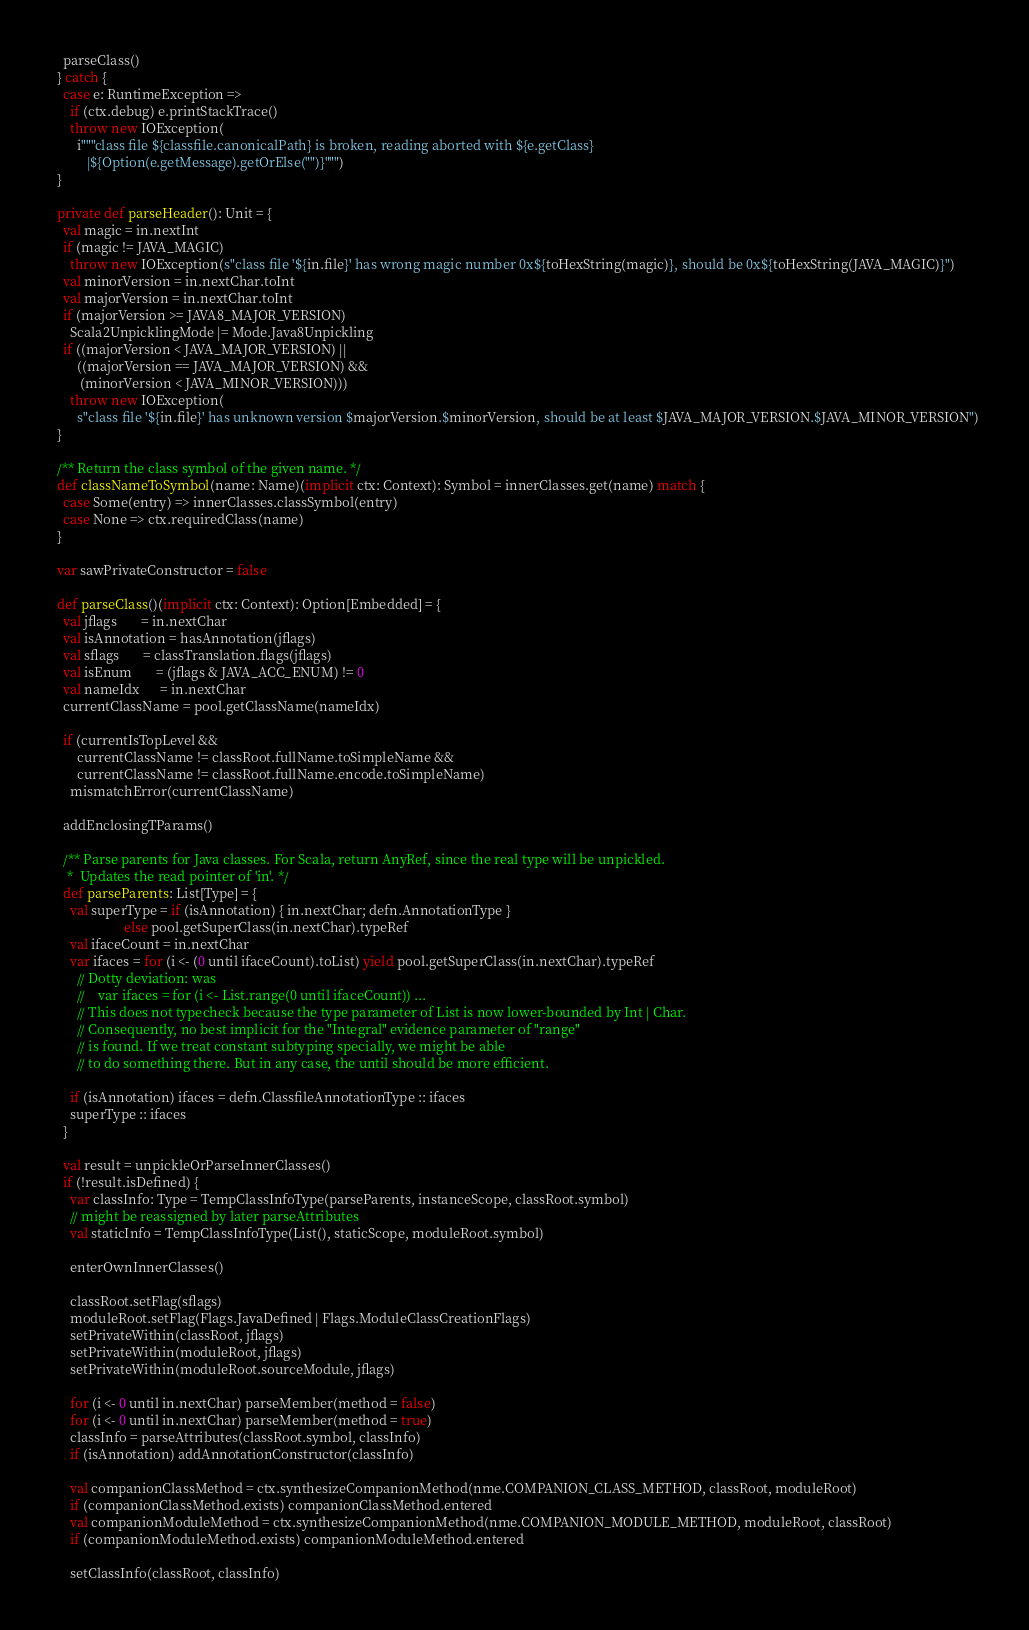<code> <loc_0><loc_0><loc_500><loc_500><_Scala_>    parseClass()
  } catch {
    case e: RuntimeException =>
      if (ctx.debug) e.printStackTrace()
      throw new IOException(
        i"""class file ${classfile.canonicalPath} is broken, reading aborted with ${e.getClass}
           |${Option(e.getMessage).getOrElse("")}""")
  }

  private def parseHeader(): Unit = {
    val magic = in.nextInt
    if (magic != JAVA_MAGIC)
      throw new IOException(s"class file '${in.file}' has wrong magic number 0x${toHexString(magic)}, should be 0x${toHexString(JAVA_MAGIC)}")
    val minorVersion = in.nextChar.toInt
    val majorVersion = in.nextChar.toInt
    if (majorVersion >= JAVA8_MAJOR_VERSION)
      Scala2UnpicklingMode |= Mode.Java8Unpickling
    if ((majorVersion < JAVA_MAJOR_VERSION) ||
        ((majorVersion == JAVA_MAJOR_VERSION) &&
         (minorVersion < JAVA_MINOR_VERSION)))
      throw new IOException(
        s"class file '${in.file}' has unknown version $majorVersion.$minorVersion, should be at least $JAVA_MAJOR_VERSION.$JAVA_MINOR_VERSION")
  }

  /** Return the class symbol of the given name. */
  def classNameToSymbol(name: Name)(implicit ctx: Context): Symbol = innerClasses.get(name) match {
    case Some(entry) => innerClasses.classSymbol(entry)
    case None => ctx.requiredClass(name)
  }

  var sawPrivateConstructor = false

  def parseClass()(implicit ctx: Context): Option[Embedded] = {
    val jflags       = in.nextChar
    val isAnnotation = hasAnnotation(jflags)
    val sflags       = classTranslation.flags(jflags)
    val isEnum       = (jflags & JAVA_ACC_ENUM) != 0
    val nameIdx      = in.nextChar
    currentClassName = pool.getClassName(nameIdx)

    if (currentIsTopLevel &&
        currentClassName != classRoot.fullName.toSimpleName &&
        currentClassName != classRoot.fullName.encode.toSimpleName)
      mismatchError(currentClassName)

    addEnclosingTParams()

    /** Parse parents for Java classes. For Scala, return AnyRef, since the real type will be unpickled.
     *  Updates the read pointer of 'in'. */
    def parseParents: List[Type] = {
      val superType = if (isAnnotation) { in.nextChar; defn.AnnotationType }
                      else pool.getSuperClass(in.nextChar).typeRef
      val ifaceCount = in.nextChar
      var ifaces = for (i <- (0 until ifaceCount).toList) yield pool.getSuperClass(in.nextChar).typeRef
        // Dotty deviation: was
        //    var ifaces = for (i <- List.range(0 until ifaceCount)) ...
        // This does not typecheck because the type parameter of List is now lower-bounded by Int | Char.
        // Consequently, no best implicit for the "Integral" evidence parameter of "range"
        // is found. If we treat constant subtyping specially, we might be able
        // to do something there. But in any case, the until should be more efficient.

      if (isAnnotation) ifaces = defn.ClassfileAnnotationType :: ifaces
      superType :: ifaces
    }

    val result = unpickleOrParseInnerClasses()
    if (!result.isDefined) {
      var classInfo: Type = TempClassInfoType(parseParents, instanceScope, classRoot.symbol)
      // might be reassigned by later parseAttributes
      val staticInfo = TempClassInfoType(List(), staticScope, moduleRoot.symbol)

      enterOwnInnerClasses()

      classRoot.setFlag(sflags)
      moduleRoot.setFlag(Flags.JavaDefined | Flags.ModuleClassCreationFlags)
      setPrivateWithin(classRoot, jflags)
      setPrivateWithin(moduleRoot, jflags)
      setPrivateWithin(moduleRoot.sourceModule, jflags)

      for (i <- 0 until in.nextChar) parseMember(method = false)
      for (i <- 0 until in.nextChar) parseMember(method = true)
      classInfo = parseAttributes(classRoot.symbol, classInfo)
      if (isAnnotation) addAnnotationConstructor(classInfo)

      val companionClassMethod = ctx.synthesizeCompanionMethod(nme.COMPANION_CLASS_METHOD, classRoot, moduleRoot)
      if (companionClassMethod.exists) companionClassMethod.entered
      val companionModuleMethod = ctx.synthesizeCompanionMethod(nme.COMPANION_MODULE_METHOD, moduleRoot, classRoot)
      if (companionModuleMethod.exists) companionModuleMethod.entered

      setClassInfo(classRoot, classInfo)</code> 